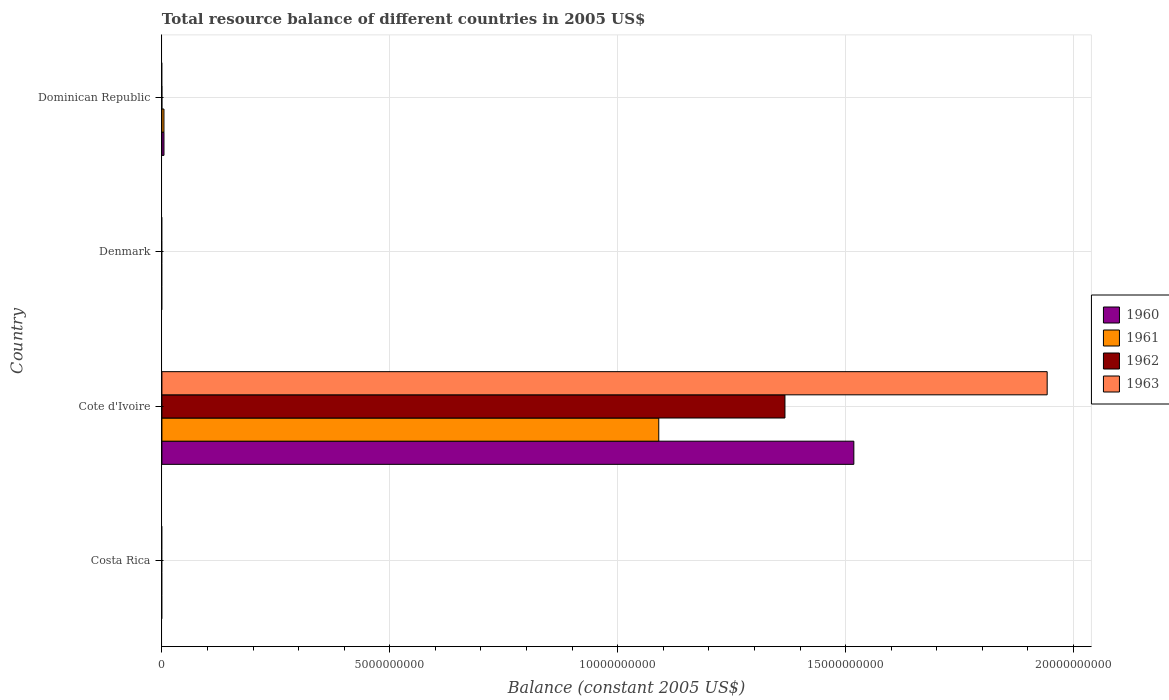Are the number of bars per tick equal to the number of legend labels?
Make the answer very short. No. How many bars are there on the 1st tick from the bottom?
Ensure brevity in your answer.  0. Across all countries, what is the maximum total resource balance in 1961?
Give a very brief answer. 1.09e+1. In which country was the total resource balance in 1962 maximum?
Your response must be concise. Cote d'Ivoire. What is the total total resource balance in 1960 in the graph?
Provide a short and direct response. 1.52e+1. What is the average total resource balance in 1963 per country?
Your response must be concise. 4.86e+09. What is the difference between the total resource balance in 1963 and total resource balance in 1961 in Cote d'Ivoire?
Offer a very short reply. 8.52e+09. What is the ratio of the total resource balance in 1961 in Cote d'Ivoire to that in Dominican Republic?
Offer a very short reply. 241.17. What is the difference between the highest and the lowest total resource balance in 1960?
Keep it short and to the point. 1.52e+1. Is the sum of the total resource balance in 1961 in Cote d'Ivoire and Dominican Republic greater than the maximum total resource balance in 1960 across all countries?
Your response must be concise. No. Is it the case that in every country, the sum of the total resource balance in 1961 and total resource balance in 1960 is greater than the sum of total resource balance in 1962 and total resource balance in 1963?
Make the answer very short. No. Is it the case that in every country, the sum of the total resource balance in 1960 and total resource balance in 1963 is greater than the total resource balance in 1962?
Offer a very short reply. No. Are all the bars in the graph horizontal?
Your answer should be very brief. Yes. Are the values on the major ticks of X-axis written in scientific E-notation?
Your response must be concise. No. Does the graph contain any zero values?
Your response must be concise. Yes. Does the graph contain grids?
Offer a very short reply. Yes. How are the legend labels stacked?
Your answer should be compact. Vertical. What is the title of the graph?
Your answer should be compact. Total resource balance of different countries in 2005 US$. What is the label or title of the X-axis?
Offer a terse response. Balance (constant 2005 US$). What is the Balance (constant 2005 US$) of 1960 in Costa Rica?
Give a very brief answer. 0. What is the Balance (constant 2005 US$) in 1963 in Costa Rica?
Your response must be concise. 0. What is the Balance (constant 2005 US$) of 1960 in Cote d'Ivoire?
Provide a short and direct response. 1.52e+1. What is the Balance (constant 2005 US$) of 1961 in Cote d'Ivoire?
Give a very brief answer. 1.09e+1. What is the Balance (constant 2005 US$) of 1962 in Cote d'Ivoire?
Give a very brief answer. 1.37e+1. What is the Balance (constant 2005 US$) in 1963 in Cote d'Ivoire?
Your answer should be very brief. 1.94e+1. What is the Balance (constant 2005 US$) in 1960 in Dominican Republic?
Your response must be concise. 4.56e+07. What is the Balance (constant 2005 US$) in 1961 in Dominican Republic?
Your answer should be very brief. 4.52e+07. What is the Balance (constant 2005 US$) in 1962 in Dominican Republic?
Give a very brief answer. 0. What is the Balance (constant 2005 US$) of 1963 in Dominican Republic?
Offer a very short reply. 0. Across all countries, what is the maximum Balance (constant 2005 US$) in 1960?
Keep it short and to the point. 1.52e+1. Across all countries, what is the maximum Balance (constant 2005 US$) in 1961?
Provide a short and direct response. 1.09e+1. Across all countries, what is the maximum Balance (constant 2005 US$) of 1962?
Ensure brevity in your answer.  1.37e+1. Across all countries, what is the maximum Balance (constant 2005 US$) in 1963?
Keep it short and to the point. 1.94e+1. Across all countries, what is the minimum Balance (constant 2005 US$) of 1960?
Keep it short and to the point. 0. Across all countries, what is the minimum Balance (constant 2005 US$) of 1961?
Your answer should be compact. 0. Across all countries, what is the minimum Balance (constant 2005 US$) in 1963?
Offer a very short reply. 0. What is the total Balance (constant 2005 US$) in 1960 in the graph?
Offer a terse response. 1.52e+1. What is the total Balance (constant 2005 US$) in 1961 in the graph?
Provide a short and direct response. 1.09e+1. What is the total Balance (constant 2005 US$) in 1962 in the graph?
Offer a terse response. 1.37e+1. What is the total Balance (constant 2005 US$) of 1963 in the graph?
Give a very brief answer. 1.94e+1. What is the difference between the Balance (constant 2005 US$) of 1960 in Cote d'Ivoire and that in Dominican Republic?
Your answer should be very brief. 1.51e+1. What is the difference between the Balance (constant 2005 US$) in 1961 in Cote d'Ivoire and that in Dominican Republic?
Keep it short and to the point. 1.09e+1. What is the difference between the Balance (constant 2005 US$) in 1960 in Cote d'Ivoire and the Balance (constant 2005 US$) in 1961 in Dominican Republic?
Give a very brief answer. 1.51e+1. What is the average Balance (constant 2005 US$) of 1960 per country?
Give a very brief answer. 3.81e+09. What is the average Balance (constant 2005 US$) in 1961 per country?
Make the answer very short. 2.74e+09. What is the average Balance (constant 2005 US$) of 1962 per country?
Provide a short and direct response. 3.42e+09. What is the average Balance (constant 2005 US$) of 1963 per country?
Your answer should be compact. 4.86e+09. What is the difference between the Balance (constant 2005 US$) in 1960 and Balance (constant 2005 US$) in 1961 in Cote d'Ivoire?
Ensure brevity in your answer.  4.28e+09. What is the difference between the Balance (constant 2005 US$) of 1960 and Balance (constant 2005 US$) of 1962 in Cote d'Ivoire?
Make the answer very short. 1.51e+09. What is the difference between the Balance (constant 2005 US$) in 1960 and Balance (constant 2005 US$) in 1963 in Cote d'Ivoire?
Your answer should be compact. -4.24e+09. What is the difference between the Balance (constant 2005 US$) in 1961 and Balance (constant 2005 US$) in 1962 in Cote d'Ivoire?
Offer a terse response. -2.77e+09. What is the difference between the Balance (constant 2005 US$) of 1961 and Balance (constant 2005 US$) of 1963 in Cote d'Ivoire?
Offer a terse response. -8.52e+09. What is the difference between the Balance (constant 2005 US$) in 1962 and Balance (constant 2005 US$) in 1963 in Cote d'Ivoire?
Ensure brevity in your answer.  -5.75e+09. What is the ratio of the Balance (constant 2005 US$) of 1960 in Cote d'Ivoire to that in Dominican Republic?
Ensure brevity in your answer.  332.91. What is the ratio of the Balance (constant 2005 US$) in 1961 in Cote d'Ivoire to that in Dominican Republic?
Your response must be concise. 241.17. What is the difference between the highest and the lowest Balance (constant 2005 US$) in 1960?
Give a very brief answer. 1.52e+1. What is the difference between the highest and the lowest Balance (constant 2005 US$) in 1961?
Offer a terse response. 1.09e+1. What is the difference between the highest and the lowest Balance (constant 2005 US$) in 1962?
Your response must be concise. 1.37e+1. What is the difference between the highest and the lowest Balance (constant 2005 US$) in 1963?
Offer a terse response. 1.94e+1. 